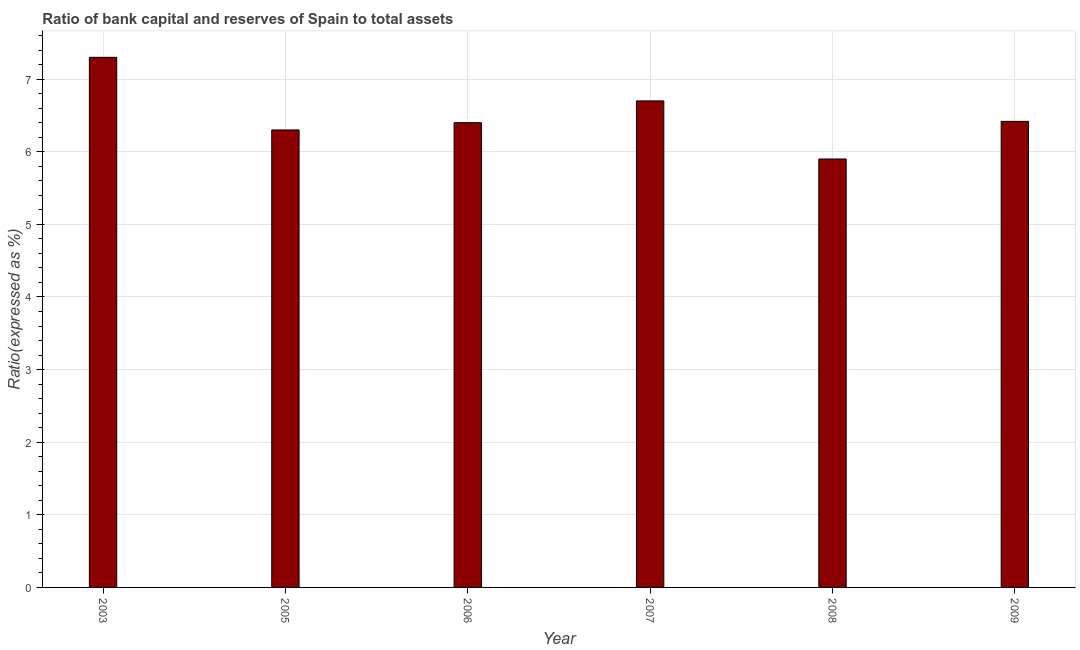Does the graph contain any zero values?
Keep it short and to the point. No. What is the title of the graph?
Give a very brief answer. Ratio of bank capital and reserves of Spain to total assets. What is the label or title of the Y-axis?
Your answer should be very brief. Ratio(expressed as %). What is the sum of the bank capital to assets ratio?
Ensure brevity in your answer.  39.02. What is the difference between the bank capital to assets ratio in 2006 and 2008?
Your answer should be compact. 0.5. What is the average bank capital to assets ratio per year?
Keep it short and to the point. 6.5. What is the median bank capital to assets ratio?
Give a very brief answer. 6.41. Do a majority of the years between 2008 and 2007 (inclusive) have bank capital to assets ratio greater than 6.8 %?
Keep it short and to the point. No. What is the ratio of the bank capital to assets ratio in 2006 to that in 2008?
Your answer should be very brief. 1.08. Is the bank capital to assets ratio in 2003 less than that in 2008?
Give a very brief answer. No. Is the sum of the bank capital to assets ratio in 2003 and 2007 greater than the maximum bank capital to assets ratio across all years?
Make the answer very short. Yes. What is the difference between the highest and the lowest bank capital to assets ratio?
Ensure brevity in your answer.  1.4. In how many years, is the bank capital to assets ratio greater than the average bank capital to assets ratio taken over all years?
Your response must be concise. 2. What is the Ratio(expressed as %) of 2003?
Offer a very short reply. 7.3. What is the Ratio(expressed as %) of 2005?
Keep it short and to the point. 6.3. What is the Ratio(expressed as %) of 2006?
Your answer should be compact. 6.4. What is the Ratio(expressed as %) of 2007?
Offer a very short reply. 6.7. What is the Ratio(expressed as %) of 2009?
Make the answer very short. 6.42. What is the difference between the Ratio(expressed as %) in 2003 and 2007?
Give a very brief answer. 0.6. What is the difference between the Ratio(expressed as %) in 2003 and 2009?
Ensure brevity in your answer.  0.88. What is the difference between the Ratio(expressed as %) in 2005 and 2006?
Offer a very short reply. -0.1. What is the difference between the Ratio(expressed as %) in 2005 and 2009?
Offer a very short reply. -0.12. What is the difference between the Ratio(expressed as %) in 2006 and 2007?
Ensure brevity in your answer.  -0.3. What is the difference between the Ratio(expressed as %) in 2006 and 2008?
Give a very brief answer. 0.5. What is the difference between the Ratio(expressed as %) in 2006 and 2009?
Offer a terse response. -0.02. What is the difference between the Ratio(expressed as %) in 2007 and 2008?
Provide a short and direct response. 0.8. What is the difference between the Ratio(expressed as %) in 2007 and 2009?
Your answer should be very brief. 0.28. What is the difference between the Ratio(expressed as %) in 2008 and 2009?
Offer a terse response. -0.52. What is the ratio of the Ratio(expressed as %) in 2003 to that in 2005?
Your answer should be compact. 1.16. What is the ratio of the Ratio(expressed as %) in 2003 to that in 2006?
Provide a succinct answer. 1.14. What is the ratio of the Ratio(expressed as %) in 2003 to that in 2007?
Make the answer very short. 1.09. What is the ratio of the Ratio(expressed as %) in 2003 to that in 2008?
Provide a short and direct response. 1.24. What is the ratio of the Ratio(expressed as %) in 2003 to that in 2009?
Make the answer very short. 1.14. What is the ratio of the Ratio(expressed as %) in 2005 to that in 2006?
Your response must be concise. 0.98. What is the ratio of the Ratio(expressed as %) in 2005 to that in 2008?
Your answer should be very brief. 1.07. What is the ratio of the Ratio(expressed as %) in 2006 to that in 2007?
Offer a very short reply. 0.95. What is the ratio of the Ratio(expressed as %) in 2006 to that in 2008?
Make the answer very short. 1.08. What is the ratio of the Ratio(expressed as %) in 2006 to that in 2009?
Your answer should be compact. 1. What is the ratio of the Ratio(expressed as %) in 2007 to that in 2008?
Make the answer very short. 1.14. What is the ratio of the Ratio(expressed as %) in 2007 to that in 2009?
Keep it short and to the point. 1.04. What is the ratio of the Ratio(expressed as %) in 2008 to that in 2009?
Provide a short and direct response. 0.92. 